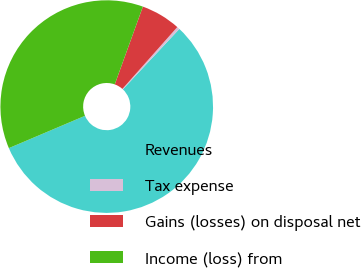Convert chart. <chart><loc_0><loc_0><loc_500><loc_500><pie_chart><fcel>Revenues<fcel>Tax expense<fcel>Gains (losses) on disposal net<fcel>Income (loss) from<nl><fcel>56.65%<fcel>0.41%<fcel>6.03%<fcel>36.91%<nl></chart> 